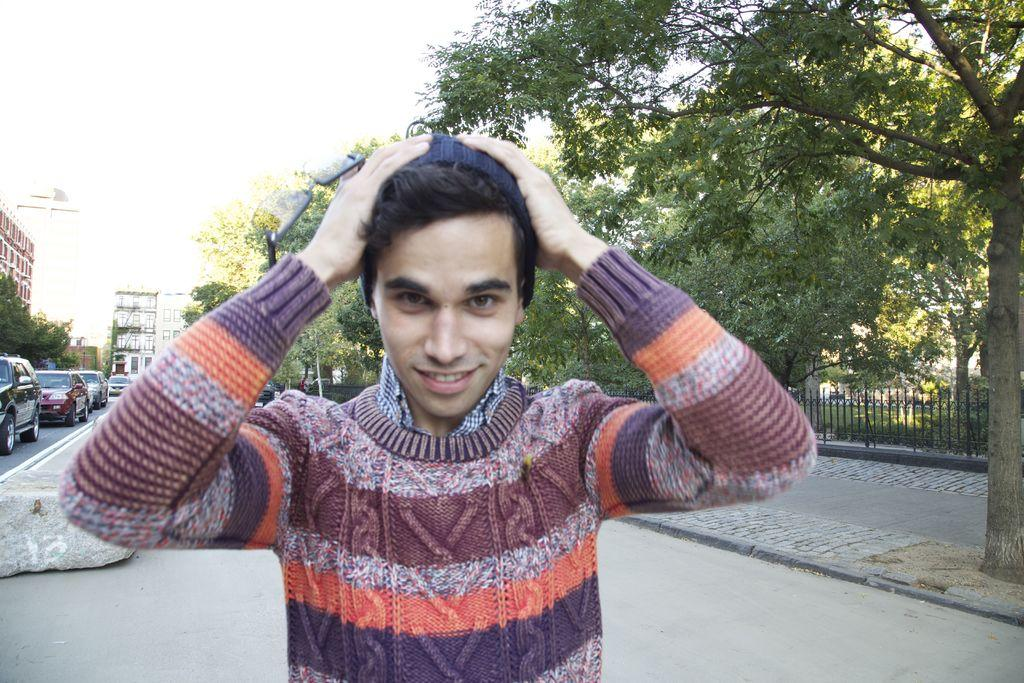What is the main subject in the foreground of the image? There is a man standing in the foreground of the image. What can be seen behind the man? There are cars visible behind the man. What type of natural scenery is present in the background of the image? There are trees in the background of the image. What type of man-made structures are visible in the background of the image? There are buildings in the background of the image. How many pizzas can be seen on the tramp in the image? There is no tramp or pizza present in the image. What type of goat is standing next to the man in the image? There is no goat present in the image. 